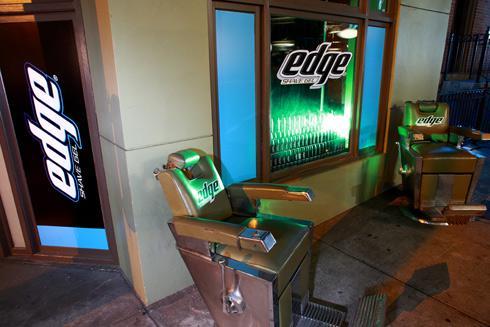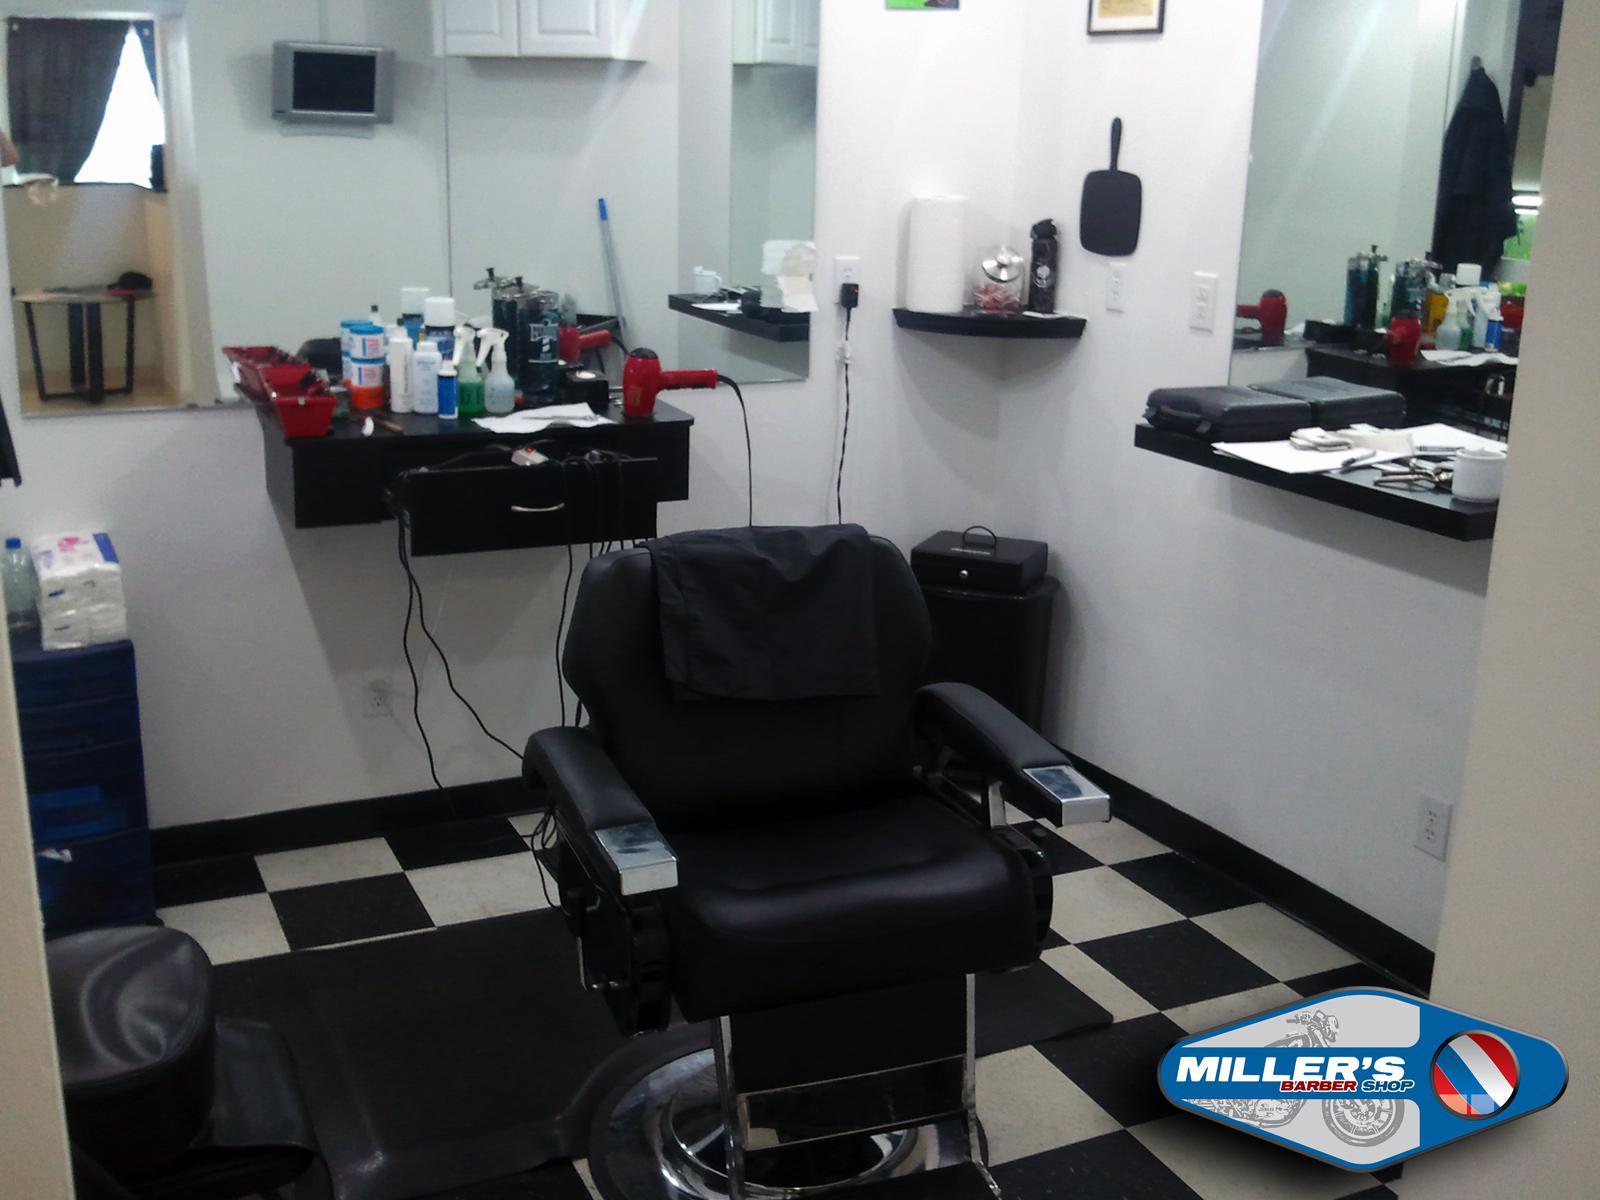The first image is the image on the left, the second image is the image on the right. Considering the images on both sides, is "One image shows a barber shop with a black and white checkerboard floor." valid? Answer yes or no. Yes. The first image is the image on the left, the second image is the image on the right. Assess this claim about the two images: "There are exactly two barber chairs in the image on the right.". Correct or not? Answer yes or no. No. 